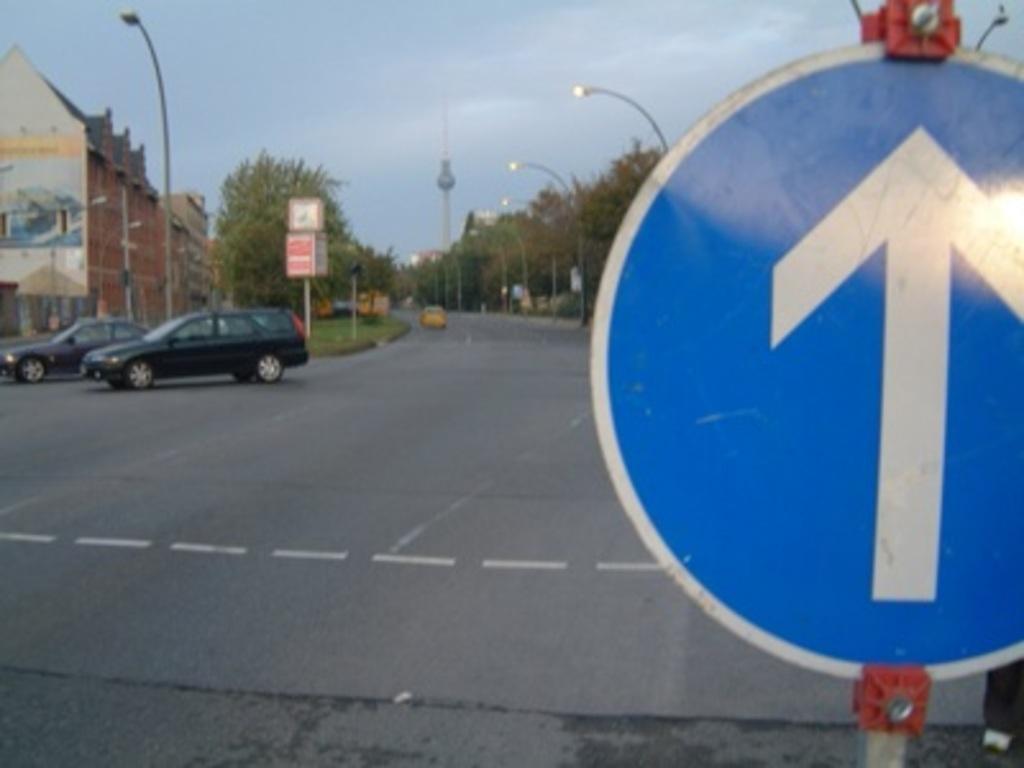Please provide a concise description of this image. In this image we can see some vehicles parked on the ground. On the left side of the image we can see some light poles, buildings and some boards, we can also see a group of trees and a signboard on a pole. At the top of the image we can see the sky. 